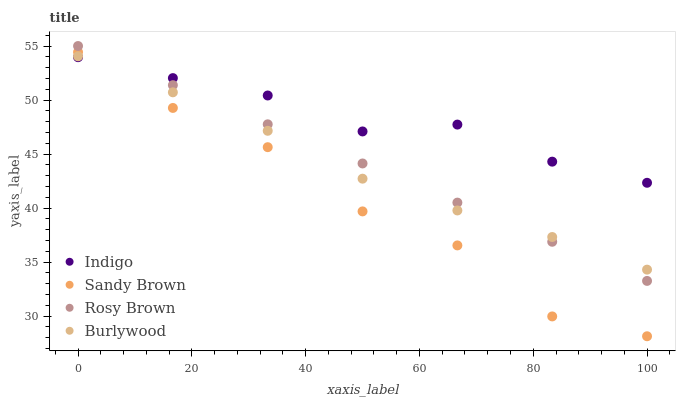Does Sandy Brown have the minimum area under the curve?
Answer yes or no. Yes. Does Indigo have the maximum area under the curve?
Answer yes or no. Yes. Does Rosy Brown have the minimum area under the curve?
Answer yes or no. No. Does Rosy Brown have the maximum area under the curve?
Answer yes or no. No. Is Rosy Brown the smoothest?
Answer yes or no. Yes. Is Sandy Brown the roughest?
Answer yes or no. Yes. Is Sandy Brown the smoothest?
Answer yes or no. No. Is Rosy Brown the roughest?
Answer yes or no. No. Does Sandy Brown have the lowest value?
Answer yes or no. Yes. Does Rosy Brown have the lowest value?
Answer yes or no. No. Does Rosy Brown have the highest value?
Answer yes or no. Yes. Does Sandy Brown have the highest value?
Answer yes or no. No. Is Sandy Brown less than Rosy Brown?
Answer yes or no. Yes. Is Rosy Brown greater than Sandy Brown?
Answer yes or no. Yes. Does Indigo intersect Sandy Brown?
Answer yes or no. Yes. Is Indigo less than Sandy Brown?
Answer yes or no. No. Is Indigo greater than Sandy Brown?
Answer yes or no. No. Does Sandy Brown intersect Rosy Brown?
Answer yes or no. No. 